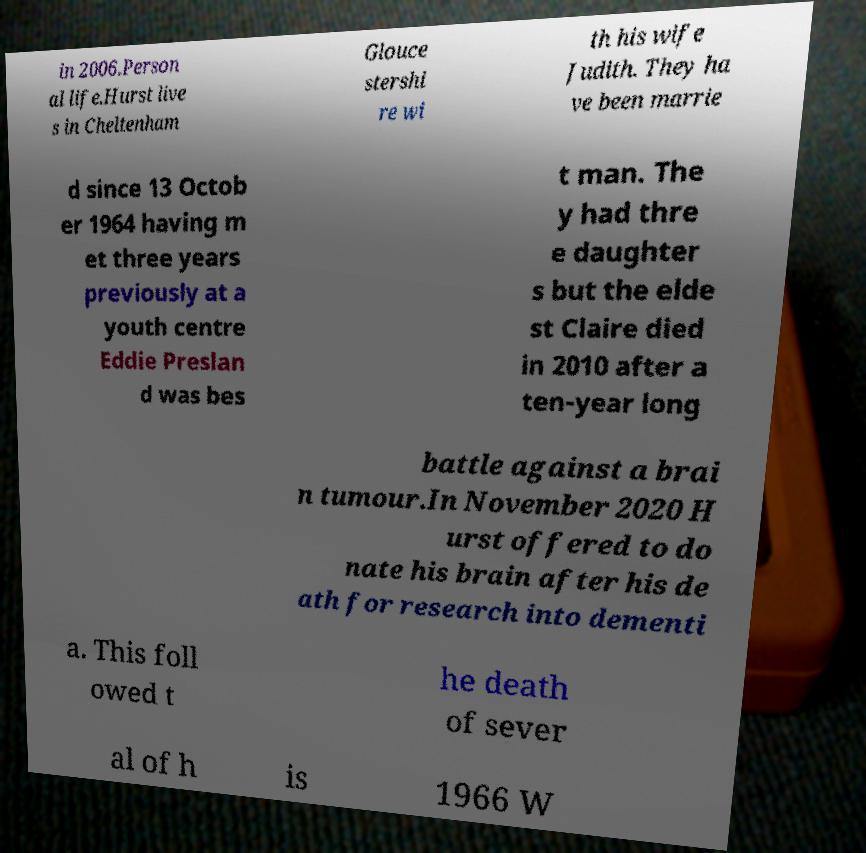What messages or text are displayed in this image? I need them in a readable, typed format. in 2006.Person al life.Hurst live s in Cheltenham Glouce stershi re wi th his wife Judith. They ha ve been marrie d since 13 Octob er 1964 having m et three years previously at a youth centre Eddie Preslan d was bes t man. The y had thre e daughter s but the elde st Claire died in 2010 after a ten-year long battle against a brai n tumour.In November 2020 H urst offered to do nate his brain after his de ath for research into dementi a. This foll owed t he death of sever al of h is 1966 W 